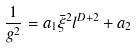Convert formula to latex. <formula><loc_0><loc_0><loc_500><loc_500>\frac { 1 } { g ^ { 2 } } = a _ { 1 } \bar { \xi } ^ { 2 } l ^ { D + 2 } + a _ { 2 }</formula> 